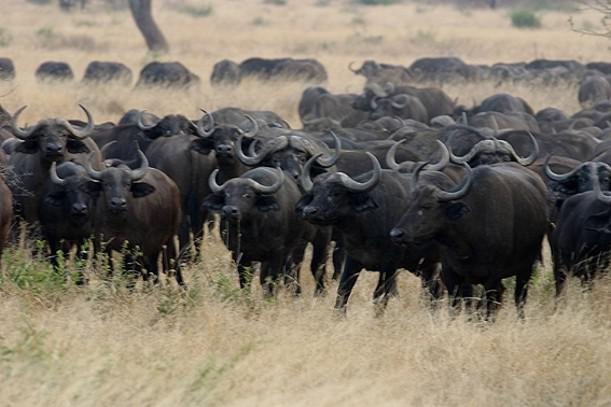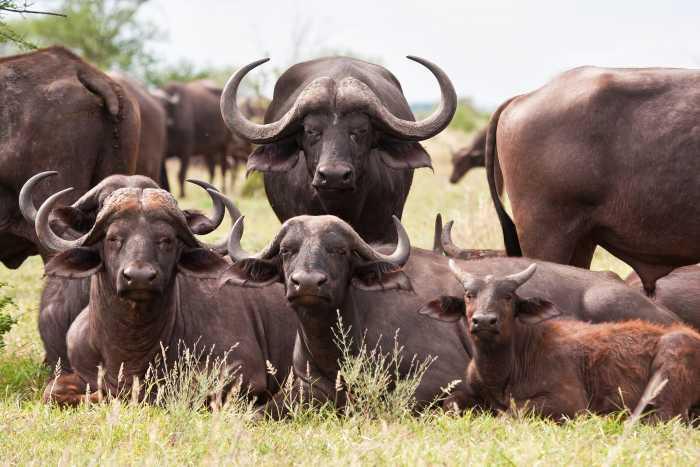The first image is the image on the left, the second image is the image on the right. Assess this claim about the two images: "Both images contains an easily visible group of buffalo with at least one facing forward and no water.". Correct or not? Answer yes or no. Yes. 